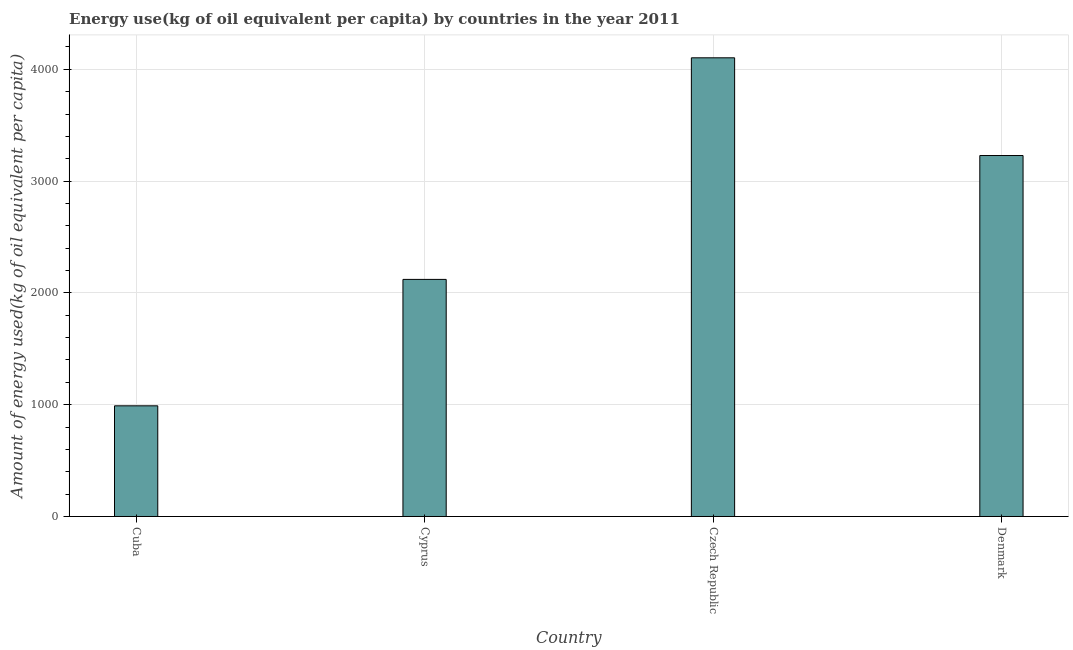What is the title of the graph?
Provide a succinct answer. Energy use(kg of oil equivalent per capita) by countries in the year 2011. What is the label or title of the Y-axis?
Your answer should be compact. Amount of energy used(kg of oil equivalent per capita). What is the amount of energy used in Cyprus?
Ensure brevity in your answer.  2120.7. Across all countries, what is the maximum amount of energy used?
Your answer should be compact. 4102.78. Across all countries, what is the minimum amount of energy used?
Ensure brevity in your answer.  989.91. In which country was the amount of energy used maximum?
Your response must be concise. Czech Republic. In which country was the amount of energy used minimum?
Offer a very short reply. Cuba. What is the sum of the amount of energy used?
Offer a terse response. 1.04e+04. What is the difference between the amount of energy used in Cyprus and Denmark?
Provide a succinct answer. -1108. What is the average amount of energy used per country?
Your response must be concise. 2610.52. What is the median amount of energy used?
Offer a very short reply. 2674.69. In how many countries, is the amount of energy used greater than 2200 kg?
Offer a terse response. 2. What is the ratio of the amount of energy used in Czech Republic to that in Denmark?
Your response must be concise. 1.27. Is the amount of energy used in Czech Republic less than that in Denmark?
Keep it short and to the point. No. Is the difference between the amount of energy used in Cyprus and Czech Republic greater than the difference between any two countries?
Make the answer very short. No. What is the difference between the highest and the second highest amount of energy used?
Ensure brevity in your answer.  874.09. Is the sum of the amount of energy used in Cuba and Czech Republic greater than the maximum amount of energy used across all countries?
Your response must be concise. Yes. What is the difference between the highest and the lowest amount of energy used?
Offer a terse response. 3112.87. In how many countries, is the amount of energy used greater than the average amount of energy used taken over all countries?
Provide a succinct answer. 2. Are all the bars in the graph horizontal?
Your response must be concise. No. Are the values on the major ticks of Y-axis written in scientific E-notation?
Provide a short and direct response. No. What is the Amount of energy used(kg of oil equivalent per capita) in Cuba?
Ensure brevity in your answer.  989.91. What is the Amount of energy used(kg of oil equivalent per capita) of Cyprus?
Your answer should be very brief. 2120.7. What is the Amount of energy used(kg of oil equivalent per capita) of Czech Republic?
Provide a short and direct response. 4102.78. What is the Amount of energy used(kg of oil equivalent per capita) in Denmark?
Your answer should be very brief. 3228.69. What is the difference between the Amount of energy used(kg of oil equivalent per capita) in Cuba and Cyprus?
Ensure brevity in your answer.  -1130.78. What is the difference between the Amount of energy used(kg of oil equivalent per capita) in Cuba and Czech Republic?
Offer a very short reply. -3112.87. What is the difference between the Amount of energy used(kg of oil equivalent per capita) in Cuba and Denmark?
Your answer should be compact. -2238.78. What is the difference between the Amount of energy used(kg of oil equivalent per capita) in Cyprus and Czech Republic?
Offer a very short reply. -1982.09. What is the difference between the Amount of energy used(kg of oil equivalent per capita) in Cyprus and Denmark?
Keep it short and to the point. -1108. What is the difference between the Amount of energy used(kg of oil equivalent per capita) in Czech Republic and Denmark?
Give a very brief answer. 874.09. What is the ratio of the Amount of energy used(kg of oil equivalent per capita) in Cuba to that in Cyprus?
Your answer should be compact. 0.47. What is the ratio of the Amount of energy used(kg of oil equivalent per capita) in Cuba to that in Czech Republic?
Provide a short and direct response. 0.24. What is the ratio of the Amount of energy used(kg of oil equivalent per capita) in Cuba to that in Denmark?
Provide a short and direct response. 0.31. What is the ratio of the Amount of energy used(kg of oil equivalent per capita) in Cyprus to that in Czech Republic?
Keep it short and to the point. 0.52. What is the ratio of the Amount of energy used(kg of oil equivalent per capita) in Cyprus to that in Denmark?
Your response must be concise. 0.66. What is the ratio of the Amount of energy used(kg of oil equivalent per capita) in Czech Republic to that in Denmark?
Keep it short and to the point. 1.27. 